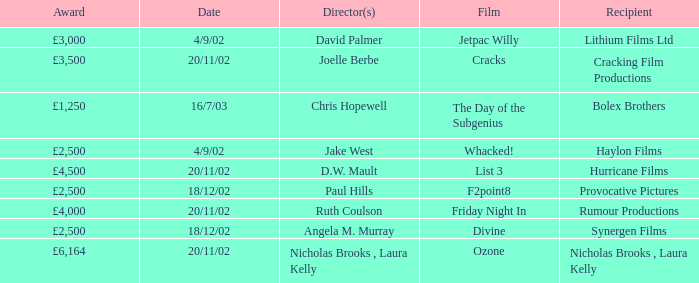Who was the recipient of a £3,000 award on april 9, 2002? Lithium Films Ltd. 